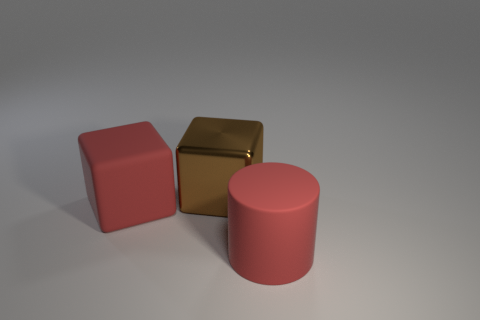Are the big brown object and the big red cylinder in front of the brown metal block made of the same material?
Your answer should be very brief. No. The object that is made of the same material as the big red cylinder is what size?
Give a very brief answer. Large. Are there more brown cubes that are to the left of the big red matte cylinder than cubes that are in front of the brown object?
Your response must be concise. No. Is there another large brown metal object of the same shape as the big metallic object?
Provide a short and direct response. No. There is a red matte object left of the brown metallic cube; is its size the same as the brown object?
Your answer should be very brief. Yes. Are there any big red things?
Offer a terse response. Yes. How many objects are either large red matte blocks that are in front of the large shiny object or red blocks?
Your answer should be compact. 1. There is a rubber cylinder; does it have the same color as the large rubber object behind the large red cylinder?
Offer a terse response. Yes. Is there a red metallic cube that has the same size as the cylinder?
Give a very brief answer. No. What material is the red object that is behind the large matte object in front of the matte cube?
Keep it short and to the point. Rubber. 